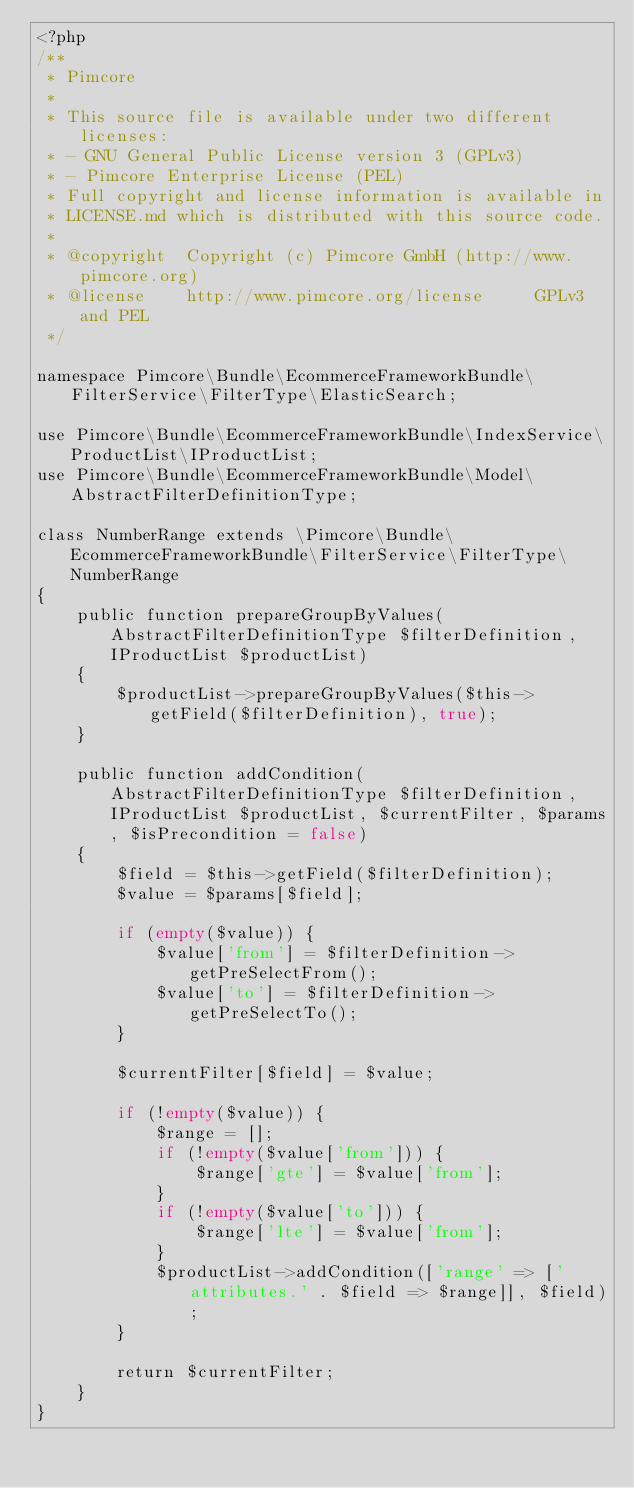<code> <loc_0><loc_0><loc_500><loc_500><_PHP_><?php
/**
 * Pimcore
 *
 * This source file is available under two different licenses:
 * - GNU General Public License version 3 (GPLv3)
 * - Pimcore Enterprise License (PEL)
 * Full copyright and license information is available in
 * LICENSE.md which is distributed with this source code.
 *
 * @copyright  Copyright (c) Pimcore GmbH (http://www.pimcore.org)
 * @license    http://www.pimcore.org/license     GPLv3 and PEL
 */

namespace Pimcore\Bundle\EcommerceFrameworkBundle\FilterService\FilterType\ElasticSearch;

use Pimcore\Bundle\EcommerceFrameworkBundle\IndexService\ProductList\IProductList;
use Pimcore\Bundle\EcommerceFrameworkBundle\Model\AbstractFilterDefinitionType;

class NumberRange extends \Pimcore\Bundle\EcommerceFrameworkBundle\FilterService\FilterType\NumberRange
{
    public function prepareGroupByValues(AbstractFilterDefinitionType $filterDefinition, IProductList $productList)
    {
        $productList->prepareGroupByValues($this->getField($filterDefinition), true);
    }

    public function addCondition(AbstractFilterDefinitionType $filterDefinition, IProductList $productList, $currentFilter, $params, $isPrecondition = false)
    {
        $field = $this->getField($filterDefinition);
        $value = $params[$field];

        if (empty($value)) {
            $value['from'] = $filterDefinition->getPreSelectFrom();
            $value['to'] = $filterDefinition->getPreSelectTo();
        }

        $currentFilter[$field] = $value;

        if (!empty($value)) {
            $range = [];
            if (!empty($value['from'])) {
                $range['gte'] = $value['from'];
            }
            if (!empty($value['to'])) {
                $range['lte'] = $value['from'];
            }
            $productList->addCondition(['range' => ['attributes.' . $field => $range]], $field);
        }

        return $currentFilter;
    }
}
</code> 